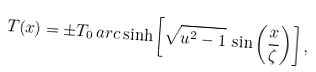<formula> <loc_0><loc_0><loc_500><loc_500>T ( x ) = \pm T _ { 0 } \, a r c \sinh \left [ \sqrt { u ^ { 2 } - 1 } \, \sin \left ( \frac { x } { \zeta } \right ) \right ] ,</formula> 